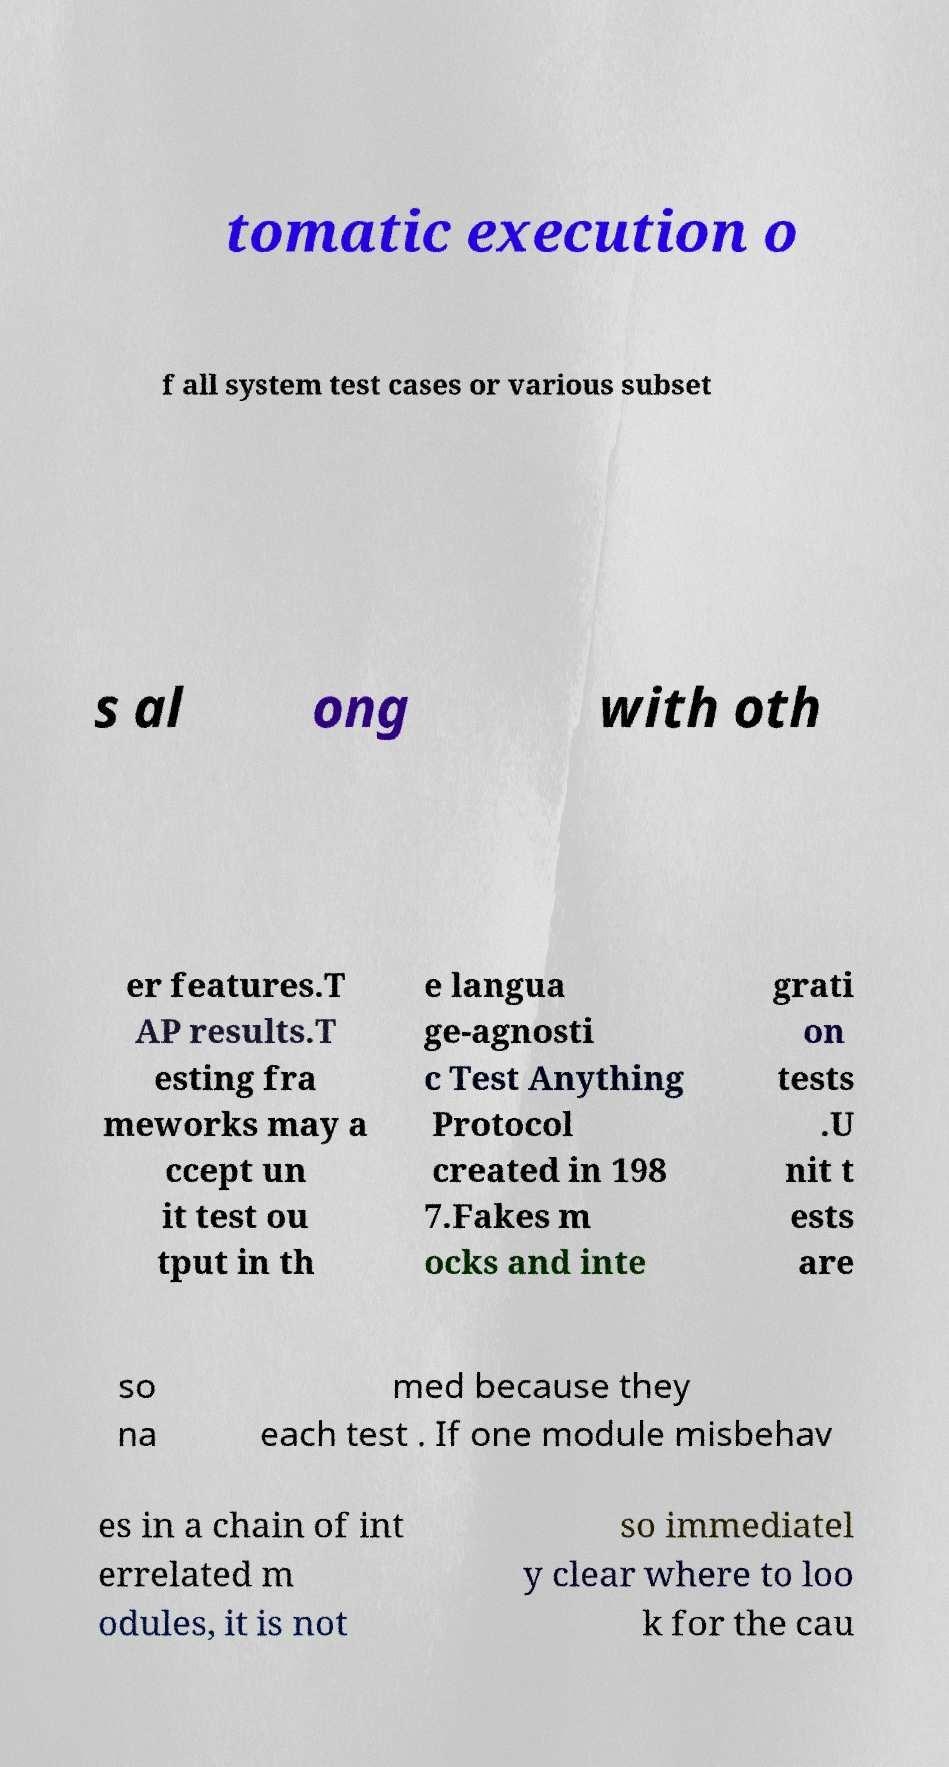Could you assist in decoding the text presented in this image and type it out clearly? tomatic execution o f all system test cases or various subset s al ong with oth er features.T AP results.T esting fra meworks may a ccept un it test ou tput in th e langua ge-agnosti c Test Anything Protocol created in 198 7.Fakes m ocks and inte grati on tests .U nit t ests are so na med because they each test . If one module misbehav es in a chain of int errelated m odules, it is not so immediatel y clear where to loo k for the cau 